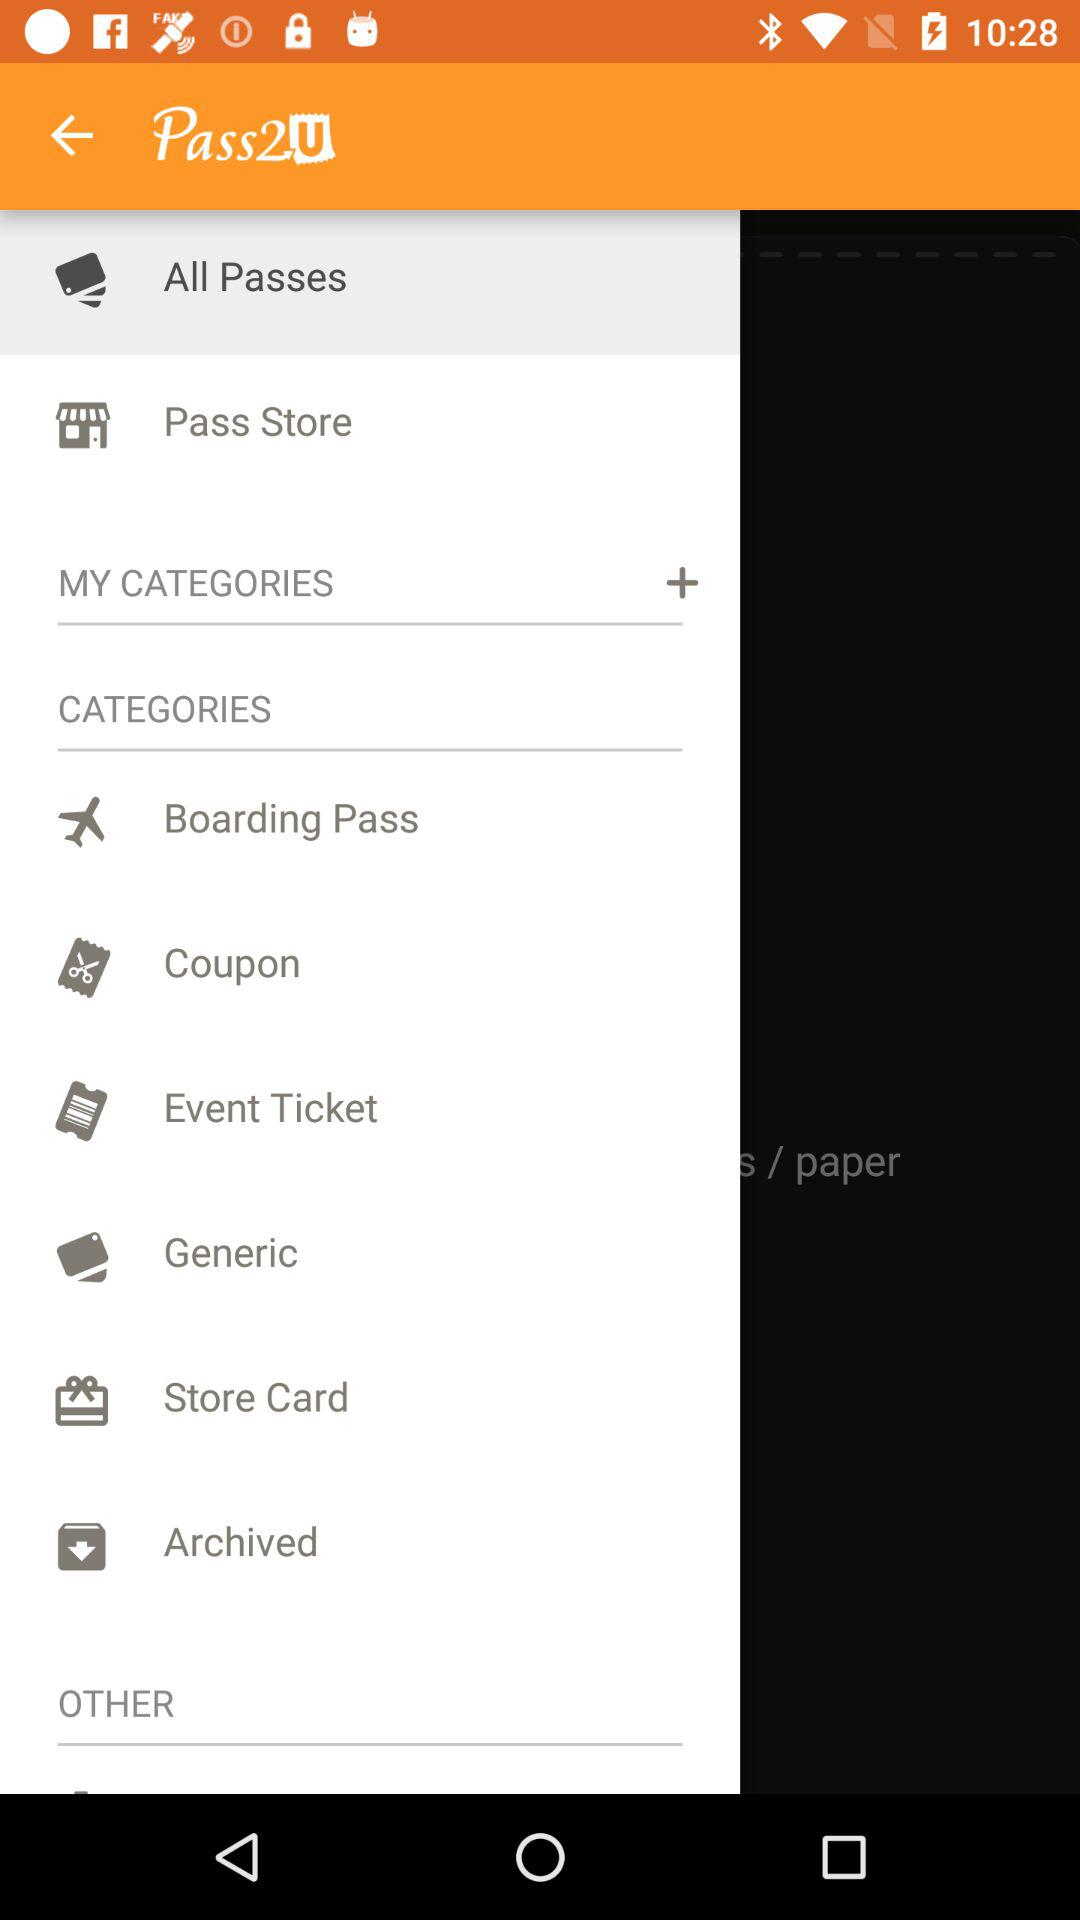Which boarding passes have been archived?
When the provided information is insufficient, respond with <no answer>. <no answer> 